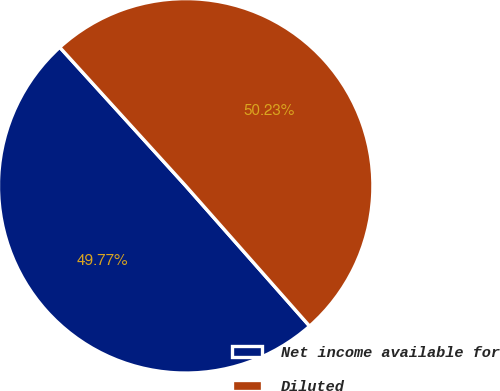Convert chart. <chart><loc_0><loc_0><loc_500><loc_500><pie_chart><fcel>Net income available for<fcel>Diluted<nl><fcel>49.77%<fcel>50.23%<nl></chart> 